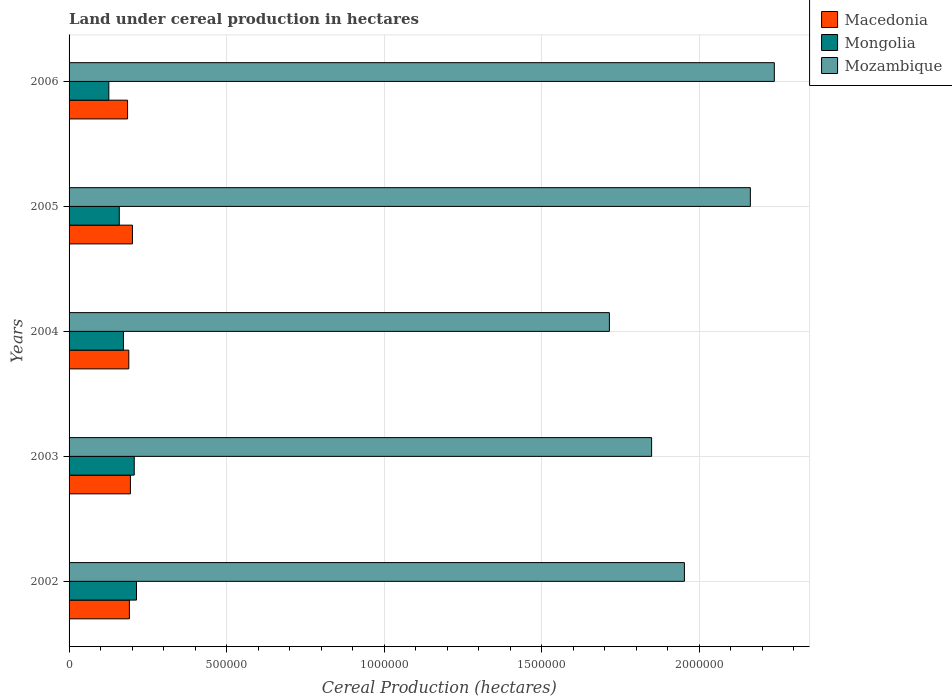How many different coloured bars are there?
Offer a very short reply. 3. Are the number of bars on each tick of the Y-axis equal?
Your answer should be very brief. Yes. How many bars are there on the 3rd tick from the top?
Ensure brevity in your answer.  3. How many bars are there on the 2nd tick from the bottom?
Ensure brevity in your answer.  3. What is the land under cereal production in Macedonia in 2004?
Make the answer very short. 1.90e+05. Across all years, what is the maximum land under cereal production in Mongolia?
Provide a succinct answer. 2.14e+05. Across all years, what is the minimum land under cereal production in Mongolia?
Provide a short and direct response. 1.26e+05. In which year was the land under cereal production in Mongolia maximum?
Provide a succinct answer. 2002. In which year was the land under cereal production in Macedonia minimum?
Offer a terse response. 2006. What is the total land under cereal production in Mongolia in the graph?
Your response must be concise. 8.79e+05. What is the difference between the land under cereal production in Mozambique in 2002 and that in 2003?
Keep it short and to the point. 1.04e+05. What is the difference between the land under cereal production in Mozambique in 2004 and the land under cereal production in Macedonia in 2003?
Give a very brief answer. 1.52e+06. What is the average land under cereal production in Mongolia per year?
Provide a succinct answer. 1.76e+05. In the year 2004, what is the difference between the land under cereal production in Mongolia and land under cereal production in Mozambique?
Offer a terse response. -1.54e+06. What is the ratio of the land under cereal production in Macedonia in 2004 to that in 2006?
Provide a succinct answer. 1.02. Is the difference between the land under cereal production in Mongolia in 2002 and 2004 greater than the difference between the land under cereal production in Mozambique in 2002 and 2004?
Your answer should be very brief. No. What is the difference between the highest and the second highest land under cereal production in Macedonia?
Give a very brief answer. 6403. What is the difference between the highest and the lowest land under cereal production in Macedonia?
Give a very brief answer. 1.55e+04. Is the sum of the land under cereal production in Macedonia in 2004 and 2006 greater than the maximum land under cereal production in Mozambique across all years?
Provide a succinct answer. No. What does the 1st bar from the top in 2005 represents?
Keep it short and to the point. Mozambique. What does the 1st bar from the bottom in 2004 represents?
Your answer should be very brief. Macedonia. How many years are there in the graph?
Make the answer very short. 5. Are the values on the major ticks of X-axis written in scientific E-notation?
Offer a very short reply. No. Does the graph contain any zero values?
Make the answer very short. No. Does the graph contain grids?
Offer a terse response. Yes. Where does the legend appear in the graph?
Provide a succinct answer. Top right. How many legend labels are there?
Your answer should be compact. 3. How are the legend labels stacked?
Ensure brevity in your answer.  Vertical. What is the title of the graph?
Provide a succinct answer. Land under cereal production in hectares. What is the label or title of the X-axis?
Offer a very short reply. Cereal Production (hectares). What is the label or title of the Y-axis?
Offer a very short reply. Years. What is the Cereal Production (hectares) of Macedonia in 2002?
Offer a terse response. 1.92e+05. What is the Cereal Production (hectares) in Mongolia in 2002?
Keep it short and to the point. 2.14e+05. What is the Cereal Production (hectares) of Mozambique in 2002?
Ensure brevity in your answer.  1.95e+06. What is the Cereal Production (hectares) of Macedonia in 2003?
Your answer should be compact. 1.95e+05. What is the Cereal Production (hectares) of Mongolia in 2003?
Give a very brief answer. 2.07e+05. What is the Cereal Production (hectares) of Mozambique in 2003?
Provide a succinct answer. 1.85e+06. What is the Cereal Production (hectares) of Macedonia in 2004?
Provide a succinct answer. 1.90e+05. What is the Cereal Production (hectares) in Mongolia in 2004?
Your answer should be compact. 1.73e+05. What is the Cereal Production (hectares) in Mozambique in 2004?
Give a very brief answer. 1.72e+06. What is the Cereal Production (hectares) of Macedonia in 2005?
Provide a short and direct response. 2.01e+05. What is the Cereal Production (hectares) of Mongolia in 2005?
Offer a terse response. 1.59e+05. What is the Cereal Production (hectares) of Mozambique in 2005?
Your answer should be very brief. 2.16e+06. What is the Cereal Production (hectares) of Macedonia in 2006?
Your answer should be compact. 1.86e+05. What is the Cereal Production (hectares) in Mongolia in 2006?
Your answer should be compact. 1.26e+05. What is the Cereal Production (hectares) in Mozambique in 2006?
Provide a short and direct response. 2.24e+06. Across all years, what is the maximum Cereal Production (hectares) in Macedonia?
Your response must be concise. 2.01e+05. Across all years, what is the maximum Cereal Production (hectares) of Mongolia?
Your response must be concise. 2.14e+05. Across all years, what is the maximum Cereal Production (hectares) in Mozambique?
Give a very brief answer. 2.24e+06. Across all years, what is the minimum Cereal Production (hectares) in Macedonia?
Give a very brief answer. 1.86e+05. Across all years, what is the minimum Cereal Production (hectares) in Mongolia?
Give a very brief answer. 1.26e+05. Across all years, what is the minimum Cereal Production (hectares) of Mozambique?
Your answer should be very brief. 1.72e+06. What is the total Cereal Production (hectares) of Macedonia in the graph?
Your response must be concise. 9.63e+05. What is the total Cereal Production (hectares) in Mongolia in the graph?
Offer a very short reply. 8.79e+05. What is the total Cereal Production (hectares) in Mozambique in the graph?
Your answer should be compact. 9.92e+06. What is the difference between the Cereal Production (hectares) of Macedonia in 2002 and that in 2003?
Provide a short and direct response. -3227. What is the difference between the Cereal Production (hectares) in Mongolia in 2002 and that in 2003?
Your answer should be very brief. 7206. What is the difference between the Cereal Production (hectares) in Mozambique in 2002 and that in 2003?
Your answer should be compact. 1.04e+05. What is the difference between the Cereal Production (hectares) of Macedonia in 2002 and that in 2004?
Provide a succinct answer. 1903. What is the difference between the Cereal Production (hectares) of Mongolia in 2002 and that in 2004?
Keep it short and to the point. 4.15e+04. What is the difference between the Cereal Production (hectares) in Mozambique in 2002 and that in 2004?
Provide a succinct answer. 2.38e+05. What is the difference between the Cereal Production (hectares) in Macedonia in 2002 and that in 2005?
Provide a short and direct response. -9630. What is the difference between the Cereal Production (hectares) of Mongolia in 2002 and that in 2005?
Ensure brevity in your answer.  5.47e+04. What is the difference between the Cereal Production (hectares) in Mozambique in 2002 and that in 2005?
Your response must be concise. -2.09e+05. What is the difference between the Cereal Production (hectares) of Macedonia in 2002 and that in 2006?
Make the answer very short. 5846. What is the difference between the Cereal Production (hectares) in Mongolia in 2002 and that in 2006?
Offer a very short reply. 8.79e+04. What is the difference between the Cereal Production (hectares) of Mozambique in 2002 and that in 2006?
Provide a succinct answer. -2.85e+05. What is the difference between the Cereal Production (hectares) in Macedonia in 2003 and that in 2004?
Give a very brief answer. 5130. What is the difference between the Cereal Production (hectares) in Mongolia in 2003 and that in 2004?
Provide a short and direct response. 3.43e+04. What is the difference between the Cereal Production (hectares) in Mozambique in 2003 and that in 2004?
Make the answer very short. 1.34e+05. What is the difference between the Cereal Production (hectares) in Macedonia in 2003 and that in 2005?
Offer a very short reply. -6403. What is the difference between the Cereal Production (hectares) of Mongolia in 2003 and that in 2005?
Give a very brief answer. 4.75e+04. What is the difference between the Cereal Production (hectares) of Mozambique in 2003 and that in 2005?
Your answer should be compact. -3.14e+05. What is the difference between the Cereal Production (hectares) of Macedonia in 2003 and that in 2006?
Provide a short and direct response. 9073. What is the difference between the Cereal Production (hectares) of Mongolia in 2003 and that in 2006?
Offer a very short reply. 8.07e+04. What is the difference between the Cereal Production (hectares) of Mozambique in 2003 and that in 2006?
Offer a very short reply. -3.90e+05. What is the difference between the Cereal Production (hectares) of Macedonia in 2004 and that in 2005?
Your response must be concise. -1.15e+04. What is the difference between the Cereal Production (hectares) of Mongolia in 2004 and that in 2005?
Keep it short and to the point. 1.32e+04. What is the difference between the Cereal Production (hectares) of Mozambique in 2004 and that in 2005?
Your answer should be very brief. -4.48e+05. What is the difference between the Cereal Production (hectares) in Macedonia in 2004 and that in 2006?
Your answer should be very brief. 3943. What is the difference between the Cereal Production (hectares) of Mongolia in 2004 and that in 2006?
Your response must be concise. 4.64e+04. What is the difference between the Cereal Production (hectares) in Mozambique in 2004 and that in 2006?
Ensure brevity in your answer.  -5.24e+05. What is the difference between the Cereal Production (hectares) in Macedonia in 2005 and that in 2006?
Your answer should be very brief. 1.55e+04. What is the difference between the Cereal Production (hectares) in Mongolia in 2005 and that in 2006?
Your answer should be compact. 3.32e+04. What is the difference between the Cereal Production (hectares) of Mozambique in 2005 and that in 2006?
Make the answer very short. -7.60e+04. What is the difference between the Cereal Production (hectares) in Macedonia in 2002 and the Cereal Production (hectares) in Mongolia in 2003?
Give a very brief answer. -1.54e+04. What is the difference between the Cereal Production (hectares) of Macedonia in 2002 and the Cereal Production (hectares) of Mozambique in 2003?
Keep it short and to the point. -1.66e+06. What is the difference between the Cereal Production (hectares) of Mongolia in 2002 and the Cereal Production (hectares) of Mozambique in 2003?
Provide a succinct answer. -1.64e+06. What is the difference between the Cereal Production (hectares) in Macedonia in 2002 and the Cereal Production (hectares) in Mongolia in 2004?
Ensure brevity in your answer.  1.89e+04. What is the difference between the Cereal Production (hectares) in Macedonia in 2002 and the Cereal Production (hectares) in Mozambique in 2004?
Give a very brief answer. -1.52e+06. What is the difference between the Cereal Production (hectares) of Mongolia in 2002 and the Cereal Production (hectares) of Mozambique in 2004?
Make the answer very short. -1.50e+06. What is the difference between the Cereal Production (hectares) of Macedonia in 2002 and the Cereal Production (hectares) of Mongolia in 2005?
Your answer should be compact. 3.21e+04. What is the difference between the Cereal Production (hectares) in Macedonia in 2002 and the Cereal Production (hectares) in Mozambique in 2005?
Keep it short and to the point. -1.97e+06. What is the difference between the Cereal Production (hectares) in Mongolia in 2002 and the Cereal Production (hectares) in Mozambique in 2005?
Ensure brevity in your answer.  -1.95e+06. What is the difference between the Cereal Production (hectares) of Macedonia in 2002 and the Cereal Production (hectares) of Mongolia in 2006?
Your answer should be compact. 6.53e+04. What is the difference between the Cereal Production (hectares) of Macedonia in 2002 and the Cereal Production (hectares) of Mozambique in 2006?
Ensure brevity in your answer.  -2.05e+06. What is the difference between the Cereal Production (hectares) of Mongolia in 2002 and the Cereal Production (hectares) of Mozambique in 2006?
Give a very brief answer. -2.02e+06. What is the difference between the Cereal Production (hectares) of Macedonia in 2003 and the Cereal Production (hectares) of Mongolia in 2004?
Your answer should be very brief. 2.21e+04. What is the difference between the Cereal Production (hectares) of Macedonia in 2003 and the Cereal Production (hectares) of Mozambique in 2004?
Provide a short and direct response. -1.52e+06. What is the difference between the Cereal Production (hectares) in Mongolia in 2003 and the Cereal Production (hectares) in Mozambique in 2004?
Your answer should be very brief. -1.51e+06. What is the difference between the Cereal Production (hectares) in Macedonia in 2003 and the Cereal Production (hectares) in Mongolia in 2005?
Offer a terse response. 3.53e+04. What is the difference between the Cereal Production (hectares) in Macedonia in 2003 and the Cereal Production (hectares) in Mozambique in 2005?
Provide a short and direct response. -1.97e+06. What is the difference between the Cereal Production (hectares) in Mongolia in 2003 and the Cereal Production (hectares) in Mozambique in 2005?
Your answer should be compact. -1.96e+06. What is the difference between the Cereal Production (hectares) in Macedonia in 2003 and the Cereal Production (hectares) in Mongolia in 2006?
Provide a succinct answer. 6.85e+04. What is the difference between the Cereal Production (hectares) in Macedonia in 2003 and the Cereal Production (hectares) in Mozambique in 2006?
Keep it short and to the point. -2.04e+06. What is the difference between the Cereal Production (hectares) of Mongolia in 2003 and the Cereal Production (hectares) of Mozambique in 2006?
Ensure brevity in your answer.  -2.03e+06. What is the difference between the Cereal Production (hectares) in Macedonia in 2004 and the Cereal Production (hectares) in Mongolia in 2005?
Your answer should be compact. 3.02e+04. What is the difference between the Cereal Production (hectares) in Macedonia in 2004 and the Cereal Production (hectares) in Mozambique in 2005?
Your answer should be compact. -1.97e+06. What is the difference between the Cereal Production (hectares) of Mongolia in 2004 and the Cereal Production (hectares) of Mozambique in 2005?
Ensure brevity in your answer.  -1.99e+06. What is the difference between the Cereal Production (hectares) in Macedonia in 2004 and the Cereal Production (hectares) in Mongolia in 2006?
Provide a short and direct response. 6.34e+04. What is the difference between the Cereal Production (hectares) of Macedonia in 2004 and the Cereal Production (hectares) of Mozambique in 2006?
Give a very brief answer. -2.05e+06. What is the difference between the Cereal Production (hectares) of Mongolia in 2004 and the Cereal Production (hectares) of Mozambique in 2006?
Offer a very short reply. -2.07e+06. What is the difference between the Cereal Production (hectares) of Macedonia in 2005 and the Cereal Production (hectares) of Mongolia in 2006?
Your answer should be compact. 7.49e+04. What is the difference between the Cereal Production (hectares) of Macedonia in 2005 and the Cereal Production (hectares) of Mozambique in 2006?
Offer a very short reply. -2.04e+06. What is the difference between the Cereal Production (hectares) of Mongolia in 2005 and the Cereal Production (hectares) of Mozambique in 2006?
Keep it short and to the point. -2.08e+06. What is the average Cereal Production (hectares) in Macedonia per year?
Give a very brief answer. 1.93e+05. What is the average Cereal Production (hectares) in Mongolia per year?
Offer a terse response. 1.76e+05. What is the average Cereal Production (hectares) of Mozambique per year?
Offer a terse response. 1.98e+06. In the year 2002, what is the difference between the Cereal Production (hectares) of Macedonia and Cereal Production (hectares) of Mongolia?
Keep it short and to the point. -2.26e+04. In the year 2002, what is the difference between the Cereal Production (hectares) of Macedonia and Cereal Production (hectares) of Mozambique?
Your answer should be very brief. -1.76e+06. In the year 2002, what is the difference between the Cereal Production (hectares) of Mongolia and Cereal Production (hectares) of Mozambique?
Give a very brief answer. -1.74e+06. In the year 2003, what is the difference between the Cereal Production (hectares) of Macedonia and Cereal Production (hectares) of Mongolia?
Provide a succinct answer. -1.21e+04. In the year 2003, what is the difference between the Cereal Production (hectares) of Macedonia and Cereal Production (hectares) of Mozambique?
Keep it short and to the point. -1.65e+06. In the year 2003, what is the difference between the Cereal Production (hectares) in Mongolia and Cereal Production (hectares) in Mozambique?
Give a very brief answer. -1.64e+06. In the year 2004, what is the difference between the Cereal Production (hectares) of Macedonia and Cereal Production (hectares) of Mongolia?
Make the answer very short. 1.70e+04. In the year 2004, what is the difference between the Cereal Production (hectares) of Macedonia and Cereal Production (hectares) of Mozambique?
Make the answer very short. -1.53e+06. In the year 2004, what is the difference between the Cereal Production (hectares) in Mongolia and Cereal Production (hectares) in Mozambique?
Provide a short and direct response. -1.54e+06. In the year 2005, what is the difference between the Cereal Production (hectares) in Macedonia and Cereal Production (hectares) in Mongolia?
Provide a short and direct response. 4.17e+04. In the year 2005, what is the difference between the Cereal Production (hectares) in Macedonia and Cereal Production (hectares) in Mozambique?
Offer a terse response. -1.96e+06. In the year 2005, what is the difference between the Cereal Production (hectares) in Mongolia and Cereal Production (hectares) in Mozambique?
Your response must be concise. -2.00e+06. In the year 2006, what is the difference between the Cereal Production (hectares) in Macedonia and Cereal Production (hectares) in Mongolia?
Your answer should be very brief. 5.95e+04. In the year 2006, what is the difference between the Cereal Production (hectares) in Macedonia and Cereal Production (hectares) in Mozambique?
Ensure brevity in your answer.  -2.05e+06. In the year 2006, what is the difference between the Cereal Production (hectares) in Mongolia and Cereal Production (hectares) in Mozambique?
Offer a very short reply. -2.11e+06. What is the ratio of the Cereal Production (hectares) of Macedonia in 2002 to that in 2003?
Your answer should be very brief. 0.98. What is the ratio of the Cereal Production (hectares) of Mongolia in 2002 to that in 2003?
Your response must be concise. 1.03. What is the ratio of the Cereal Production (hectares) of Mozambique in 2002 to that in 2003?
Keep it short and to the point. 1.06. What is the ratio of the Cereal Production (hectares) of Macedonia in 2002 to that in 2004?
Provide a short and direct response. 1.01. What is the ratio of the Cereal Production (hectares) in Mongolia in 2002 to that in 2004?
Offer a very short reply. 1.24. What is the ratio of the Cereal Production (hectares) of Mozambique in 2002 to that in 2004?
Provide a succinct answer. 1.14. What is the ratio of the Cereal Production (hectares) in Macedonia in 2002 to that in 2005?
Ensure brevity in your answer.  0.95. What is the ratio of the Cereal Production (hectares) in Mongolia in 2002 to that in 2005?
Offer a terse response. 1.34. What is the ratio of the Cereal Production (hectares) in Mozambique in 2002 to that in 2005?
Provide a succinct answer. 0.9. What is the ratio of the Cereal Production (hectares) in Macedonia in 2002 to that in 2006?
Your answer should be compact. 1.03. What is the ratio of the Cereal Production (hectares) in Mongolia in 2002 to that in 2006?
Provide a succinct answer. 1.7. What is the ratio of the Cereal Production (hectares) of Mozambique in 2002 to that in 2006?
Your answer should be compact. 0.87. What is the ratio of the Cereal Production (hectares) in Macedonia in 2003 to that in 2004?
Provide a succinct answer. 1.03. What is the ratio of the Cereal Production (hectares) of Mongolia in 2003 to that in 2004?
Offer a very short reply. 1.2. What is the ratio of the Cereal Production (hectares) in Mozambique in 2003 to that in 2004?
Offer a very short reply. 1.08. What is the ratio of the Cereal Production (hectares) in Macedonia in 2003 to that in 2005?
Make the answer very short. 0.97. What is the ratio of the Cereal Production (hectares) of Mongolia in 2003 to that in 2005?
Your response must be concise. 1.3. What is the ratio of the Cereal Production (hectares) of Mozambique in 2003 to that in 2005?
Give a very brief answer. 0.85. What is the ratio of the Cereal Production (hectares) of Macedonia in 2003 to that in 2006?
Your answer should be compact. 1.05. What is the ratio of the Cereal Production (hectares) of Mongolia in 2003 to that in 2006?
Provide a short and direct response. 1.64. What is the ratio of the Cereal Production (hectares) in Mozambique in 2003 to that in 2006?
Make the answer very short. 0.83. What is the ratio of the Cereal Production (hectares) in Macedonia in 2004 to that in 2005?
Make the answer very short. 0.94. What is the ratio of the Cereal Production (hectares) in Mongolia in 2004 to that in 2005?
Provide a succinct answer. 1.08. What is the ratio of the Cereal Production (hectares) of Mozambique in 2004 to that in 2005?
Keep it short and to the point. 0.79. What is the ratio of the Cereal Production (hectares) of Macedonia in 2004 to that in 2006?
Your response must be concise. 1.02. What is the ratio of the Cereal Production (hectares) of Mongolia in 2004 to that in 2006?
Your response must be concise. 1.37. What is the ratio of the Cereal Production (hectares) of Mozambique in 2004 to that in 2006?
Ensure brevity in your answer.  0.77. What is the ratio of the Cereal Production (hectares) in Macedonia in 2005 to that in 2006?
Your response must be concise. 1.08. What is the ratio of the Cereal Production (hectares) in Mongolia in 2005 to that in 2006?
Make the answer very short. 1.26. What is the ratio of the Cereal Production (hectares) in Mozambique in 2005 to that in 2006?
Make the answer very short. 0.97. What is the difference between the highest and the second highest Cereal Production (hectares) in Macedonia?
Give a very brief answer. 6403. What is the difference between the highest and the second highest Cereal Production (hectares) in Mongolia?
Give a very brief answer. 7206. What is the difference between the highest and the second highest Cereal Production (hectares) of Mozambique?
Your answer should be compact. 7.60e+04. What is the difference between the highest and the lowest Cereal Production (hectares) of Macedonia?
Provide a short and direct response. 1.55e+04. What is the difference between the highest and the lowest Cereal Production (hectares) in Mongolia?
Keep it short and to the point. 8.79e+04. What is the difference between the highest and the lowest Cereal Production (hectares) of Mozambique?
Make the answer very short. 5.24e+05. 